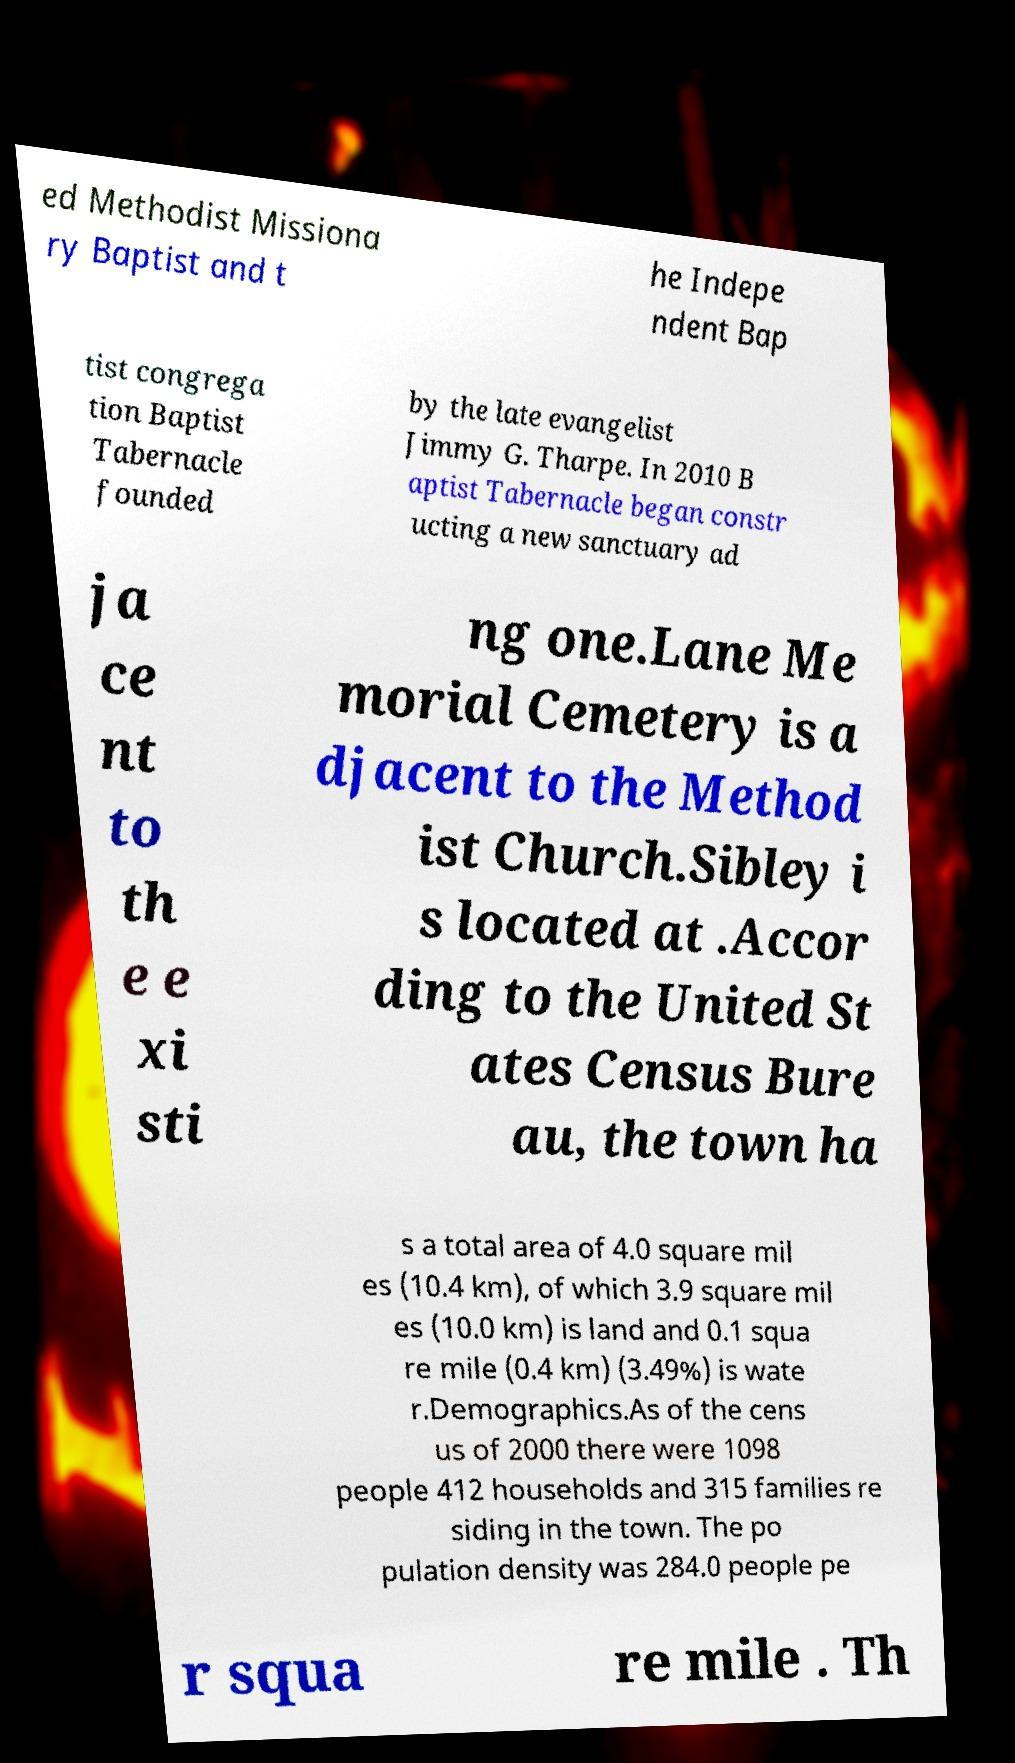Please identify and transcribe the text found in this image. ed Methodist Missiona ry Baptist and t he Indepe ndent Bap tist congrega tion Baptist Tabernacle founded by the late evangelist Jimmy G. Tharpe. In 2010 B aptist Tabernacle began constr ucting a new sanctuary ad ja ce nt to th e e xi sti ng one.Lane Me morial Cemetery is a djacent to the Method ist Church.Sibley i s located at .Accor ding to the United St ates Census Bure au, the town ha s a total area of 4.0 square mil es (10.4 km), of which 3.9 square mil es (10.0 km) is land and 0.1 squa re mile (0.4 km) (3.49%) is wate r.Demographics.As of the cens us of 2000 there were 1098 people 412 households and 315 families re siding in the town. The po pulation density was 284.0 people pe r squa re mile . Th 